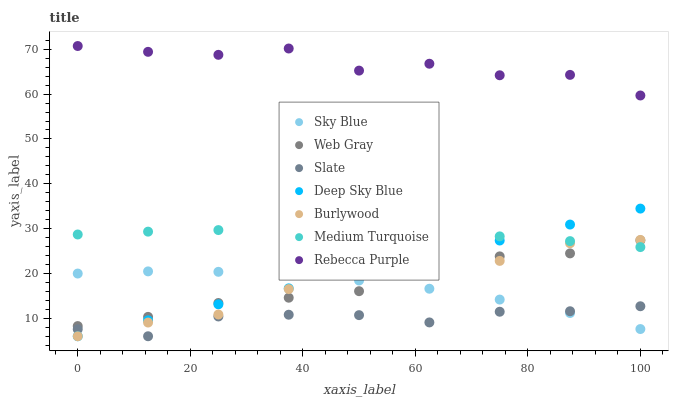Does Slate have the minimum area under the curve?
Answer yes or no. Yes. Does Rebecca Purple have the maximum area under the curve?
Answer yes or no. Yes. Does Deep Sky Blue have the minimum area under the curve?
Answer yes or no. No. Does Deep Sky Blue have the maximum area under the curve?
Answer yes or no. No. Is Deep Sky Blue the smoothest?
Answer yes or no. Yes. Is Rebecca Purple the roughest?
Answer yes or no. Yes. Is Burlywood the smoothest?
Answer yes or no. No. Is Burlywood the roughest?
Answer yes or no. No. Does Deep Sky Blue have the lowest value?
Answer yes or no. Yes. Does Rebecca Purple have the lowest value?
Answer yes or no. No. Does Rebecca Purple have the highest value?
Answer yes or no. Yes. Does Deep Sky Blue have the highest value?
Answer yes or no. No. Is Medium Turquoise less than Rebecca Purple?
Answer yes or no. Yes. Is Medium Turquoise greater than Slate?
Answer yes or no. Yes. Does Deep Sky Blue intersect Slate?
Answer yes or no. Yes. Is Deep Sky Blue less than Slate?
Answer yes or no. No. Is Deep Sky Blue greater than Slate?
Answer yes or no. No. Does Medium Turquoise intersect Rebecca Purple?
Answer yes or no. No. 